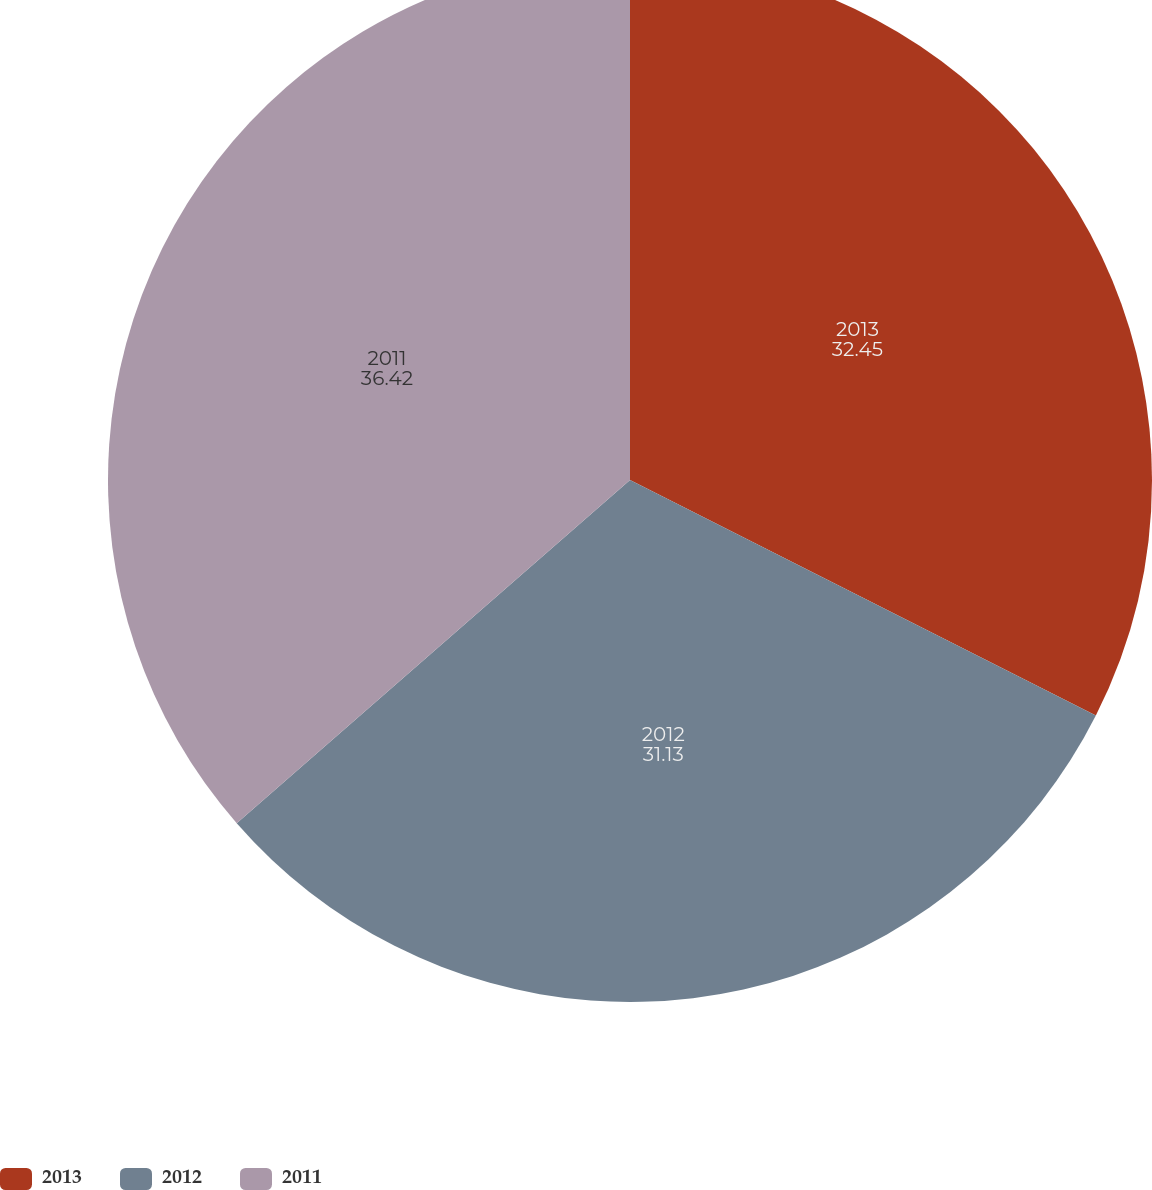<chart> <loc_0><loc_0><loc_500><loc_500><pie_chart><fcel>2013<fcel>2012<fcel>2011<nl><fcel>32.45%<fcel>31.13%<fcel>36.42%<nl></chart> 